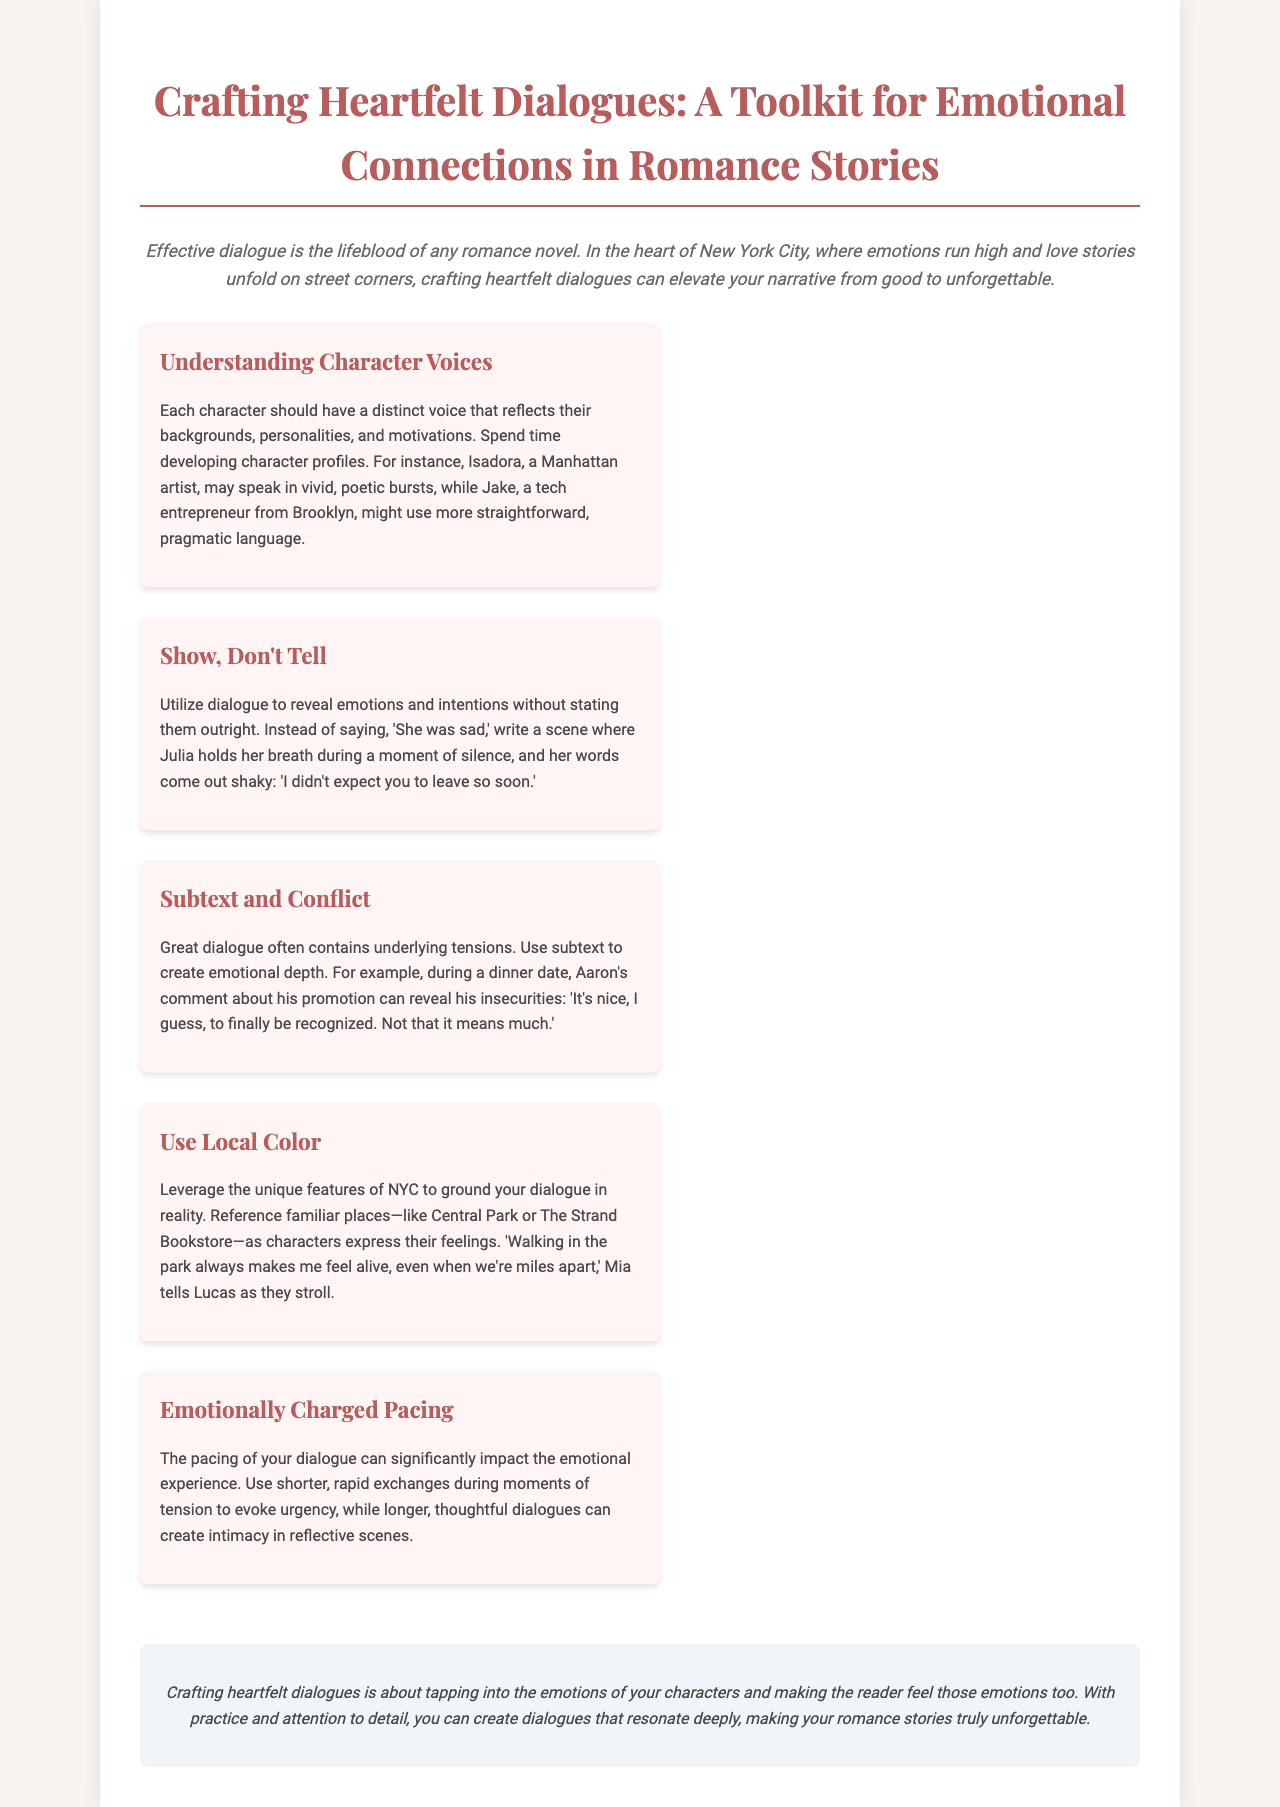What is the title of the toolkit? The title is prominently displayed at the top of the brochure, indicating the focus on crafting dialogues in romance stories.
Answer: Crafting Heartfelt Dialogues Who is the example character that might speak in vivid, poetic bursts? This is mentioned in the section about understanding character voices, illustrating the distinct voice of a character in the narrative.
Answer: Isadora What does Mia tell Lucas as they stroll? This phrase is part of the section discussing the importance of local color in dialogue, showcasing a character's expression.
Answer: "Walking in the park always makes me feel alive, even when we're miles apart." What are the two types of pacing in dialogue mentioned? These terms are discussed in the section on emotionally charged pacing, highlighting how dialogue can be structured in different scenes.
Answer: Shorter, longer What does subtext in dialogue create? This is inferred from the explanation about using subtext, indicating what it adds to the conversation between characters.
Answer: Emotional depth 